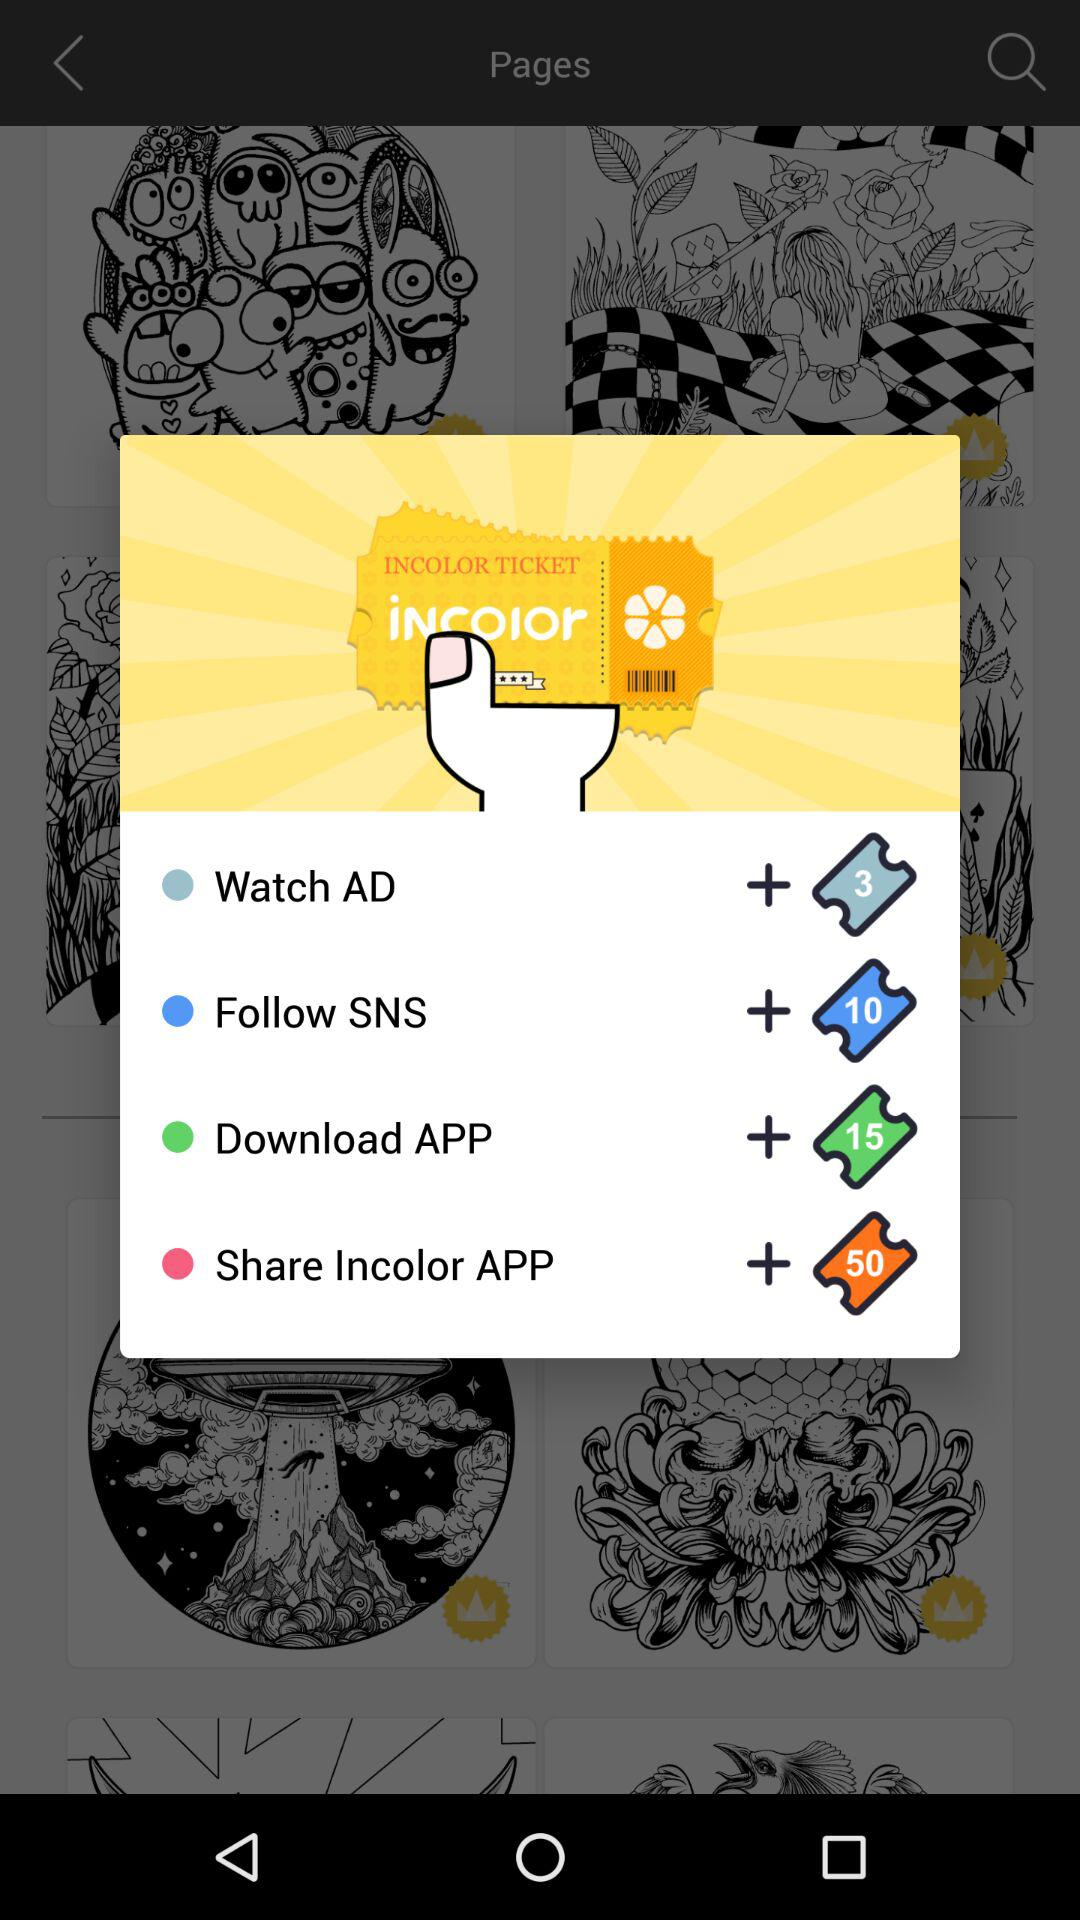What is the ticket price for share incolor application? The ticket price for share incolor application is 50. 